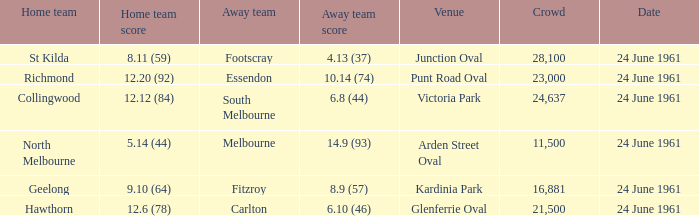What was the home team's score at the game attended by more than 24,637? 8.11 (59). 